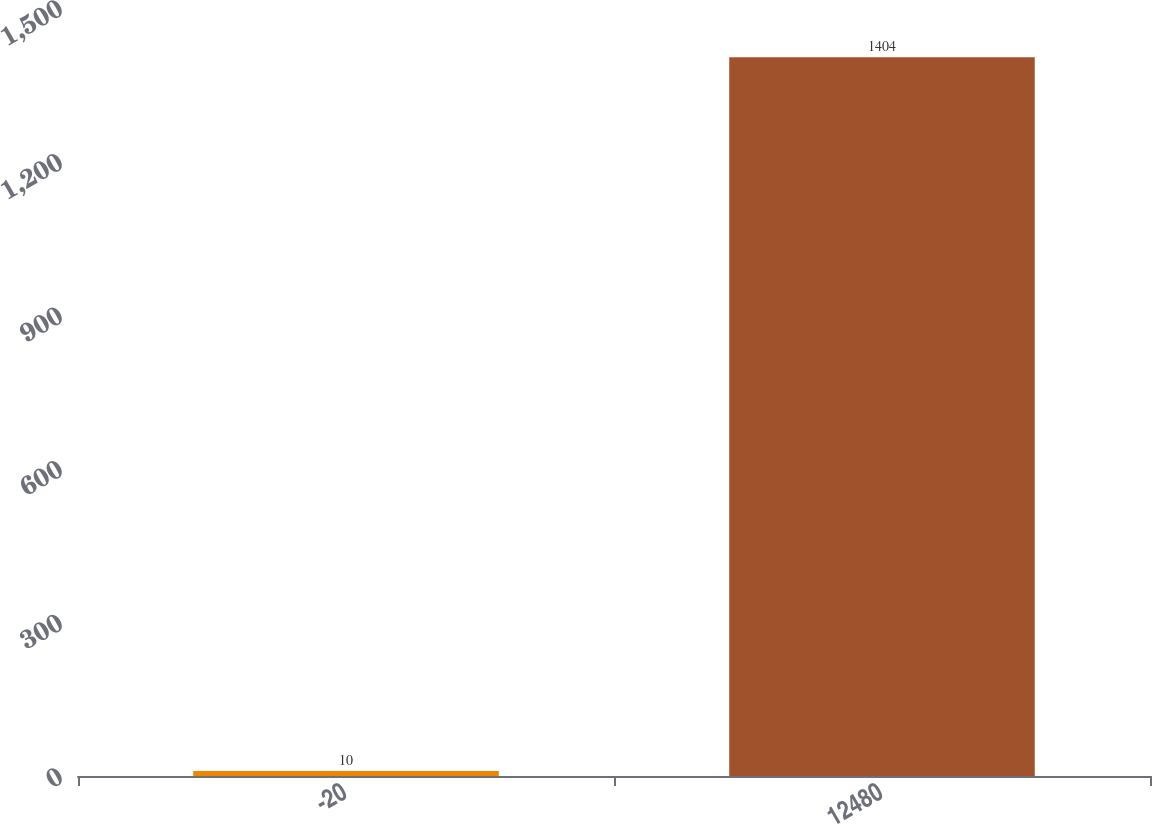<chart> <loc_0><loc_0><loc_500><loc_500><bar_chart><fcel>-20<fcel>12480<nl><fcel>10<fcel>1404<nl></chart> 